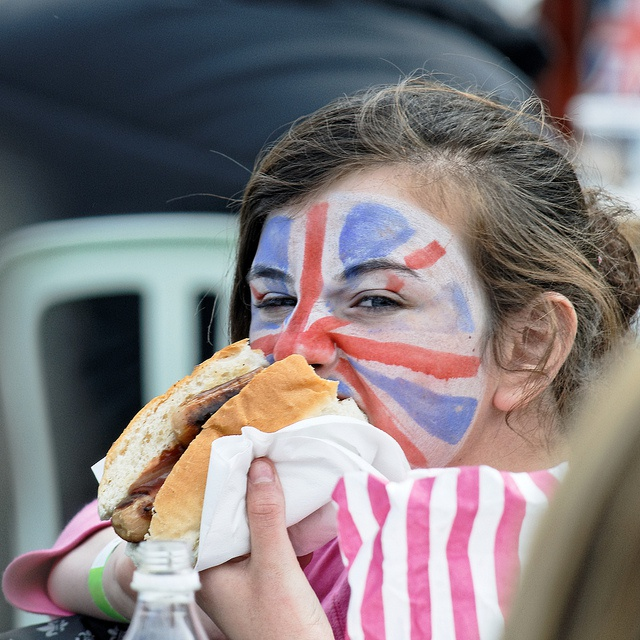Describe the objects in this image and their specific colors. I can see people in gray, lightgray, darkgray, and lightpink tones, hot dog in gray, lightgray, and tan tones, and bottle in gray, lightgray, and darkgray tones in this image. 